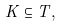Convert formula to latex. <formula><loc_0><loc_0><loc_500><loc_500>K \subseteq T ,</formula> 